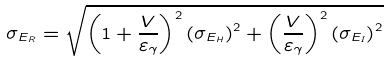Convert formula to latex. <formula><loc_0><loc_0><loc_500><loc_500>\sigma _ { E _ { R } } = \sqrt { \left ( 1 + \frac { V } { \varepsilon _ { \gamma } } \right ) ^ { 2 } \left ( \sigma _ { E _ { H } } \right ) ^ { 2 } + \left ( \frac { V } { \varepsilon _ { \gamma } } \right ) ^ { 2 } \left ( \sigma _ { E _ { I } } \right ) ^ { 2 } }</formula> 